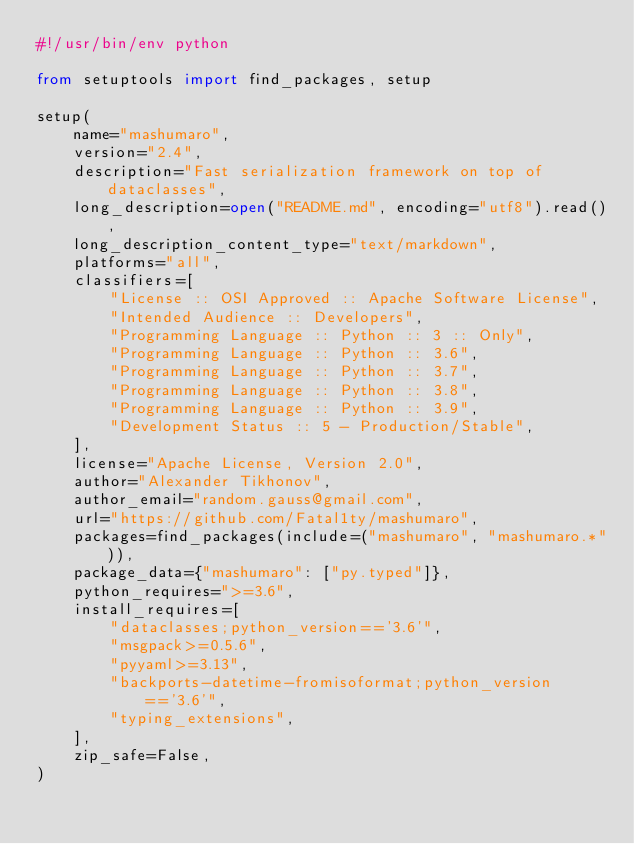Convert code to text. <code><loc_0><loc_0><loc_500><loc_500><_Python_>#!/usr/bin/env python

from setuptools import find_packages, setup

setup(
    name="mashumaro",
    version="2.4",
    description="Fast serialization framework on top of dataclasses",
    long_description=open("README.md", encoding="utf8").read(),
    long_description_content_type="text/markdown",
    platforms="all",
    classifiers=[
        "License :: OSI Approved :: Apache Software License",
        "Intended Audience :: Developers",
        "Programming Language :: Python :: 3 :: Only",
        "Programming Language :: Python :: 3.6",
        "Programming Language :: Python :: 3.7",
        "Programming Language :: Python :: 3.8",
        "Programming Language :: Python :: 3.9",
        "Development Status :: 5 - Production/Stable",
    ],
    license="Apache License, Version 2.0",
    author="Alexander Tikhonov",
    author_email="random.gauss@gmail.com",
    url="https://github.com/Fatal1ty/mashumaro",
    packages=find_packages(include=("mashumaro", "mashumaro.*")),
    package_data={"mashumaro": ["py.typed"]},
    python_requires=">=3.6",
    install_requires=[
        "dataclasses;python_version=='3.6'",
        "msgpack>=0.5.6",
        "pyyaml>=3.13",
        "backports-datetime-fromisoformat;python_version=='3.6'",
        "typing_extensions",
    ],
    zip_safe=False,
)
</code> 